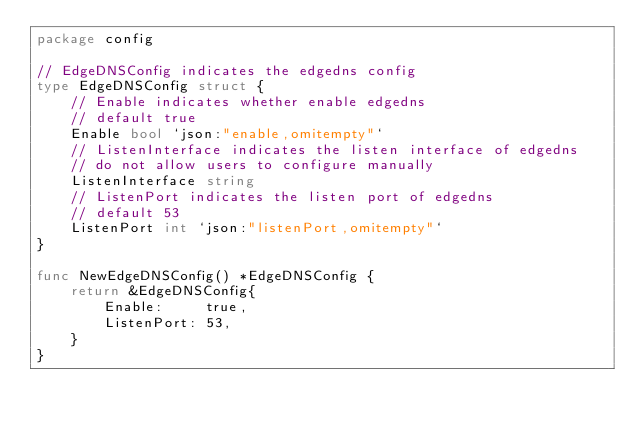Convert code to text. <code><loc_0><loc_0><loc_500><loc_500><_Go_>package config

// EdgeDNSConfig indicates the edgedns config
type EdgeDNSConfig struct {
	// Enable indicates whether enable edgedns
	// default true
	Enable bool `json:"enable,omitempty"`
	// ListenInterface indicates the listen interface of edgedns
	// do not allow users to configure manually
	ListenInterface string
	// ListenPort indicates the listen port of edgedns
	// default 53
	ListenPort int `json:"listenPort,omitempty"`
}

func NewEdgeDNSConfig() *EdgeDNSConfig {
	return &EdgeDNSConfig{
		Enable:     true,
		ListenPort: 53,
	}
}
</code> 